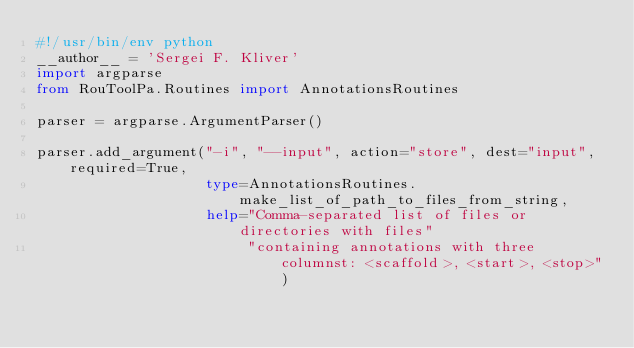<code> <loc_0><loc_0><loc_500><loc_500><_Python_>#!/usr/bin/env python
__author__ = 'Sergei F. Kliver'
import argparse
from RouToolPa.Routines import AnnotationsRoutines

parser = argparse.ArgumentParser()

parser.add_argument("-i", "--input", action="store", dest="input", required=True,
                    type=AnnotationsRoutines.make_list_of_path_to_files_from_string,
                    help="Comma-separated list of files or directories with files"
                         "containing annotations with three columnst: <scaffold>, <start>, <stop>")</code> 